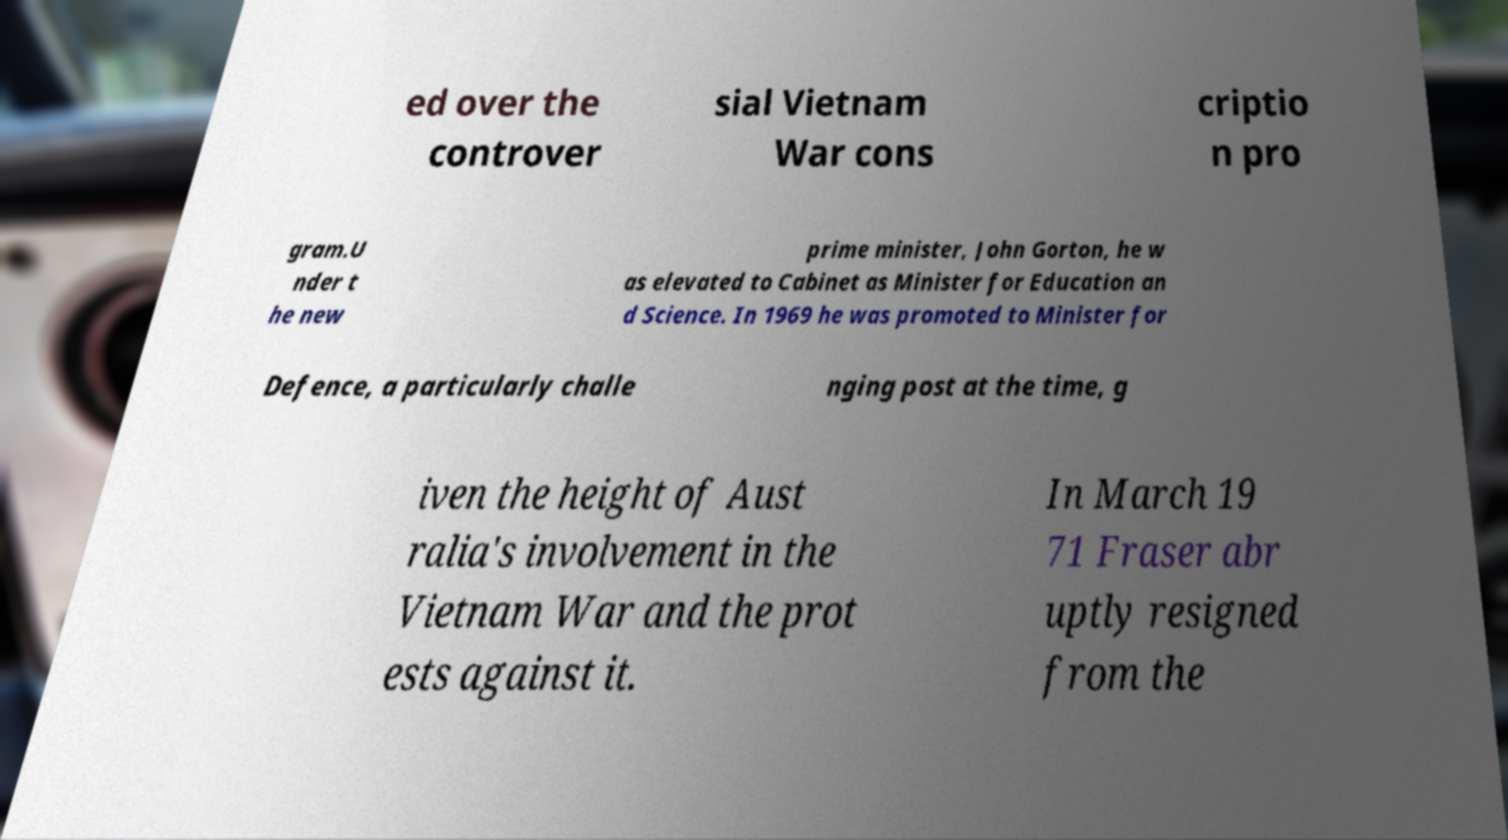Can you accurately transcribe the text from the provided image for me? ed over the controver sial Vietnam War cons criptio n pro gram.U nder t he new prime minister, John Gorton, he w as elevated to Cabinet as Minister for Education an d Science. In 1969 he was promoted to Minister for Defence, a particularly challe nging post at the time, g iven the height of Aust ralia's involvement in the Vietnam War and the prot ests against it. In March 19 71 Fraser abr uptly resigned from the 